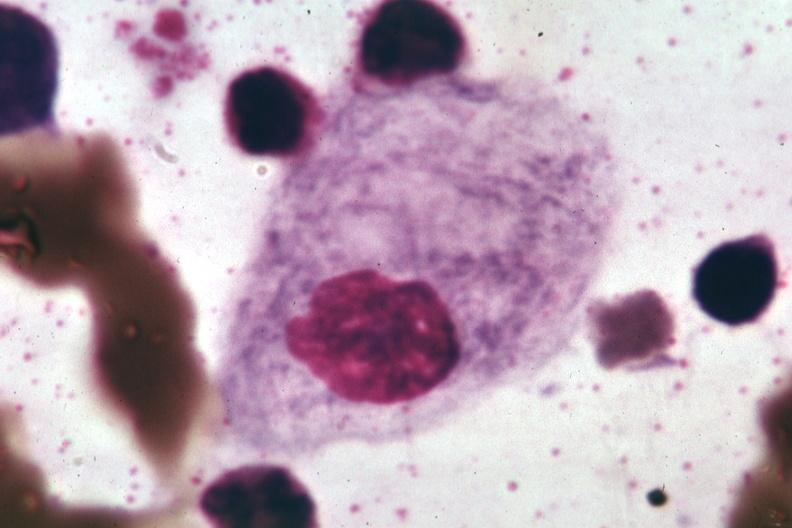s mixed mesodermal tumor present?
Answer the question using a single word or phrase. No 